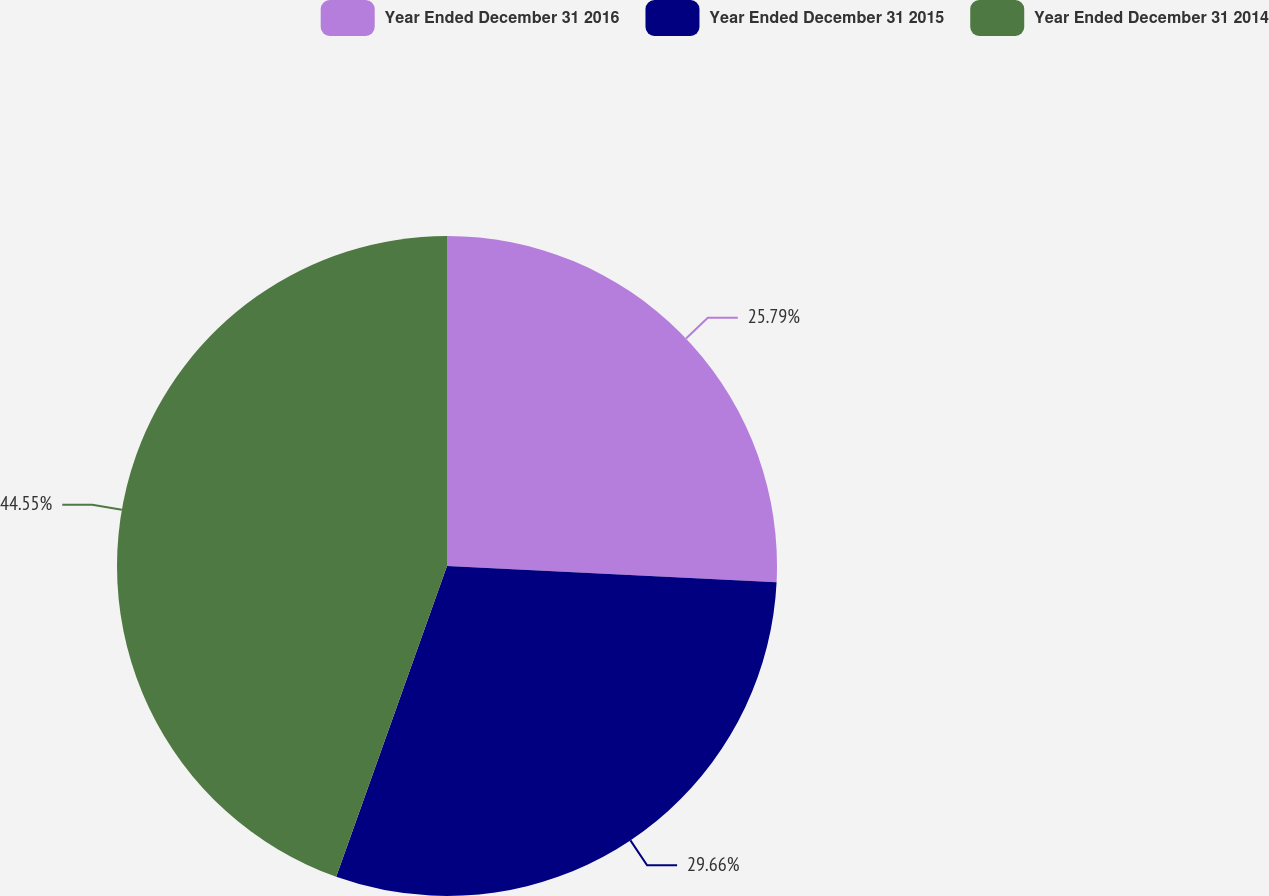Convert chart to OTSL. <chart><loc_0><loc_0><loc_500><loc_500><pie_chart><fcel>Year Ended December 31 2016<fcel>Year Ended December 31 2015<fcel>Year Ended December 31 2014<nl><fcel>25.79%<fcel>29.66%<fcel>44.55%<nl></chart> 